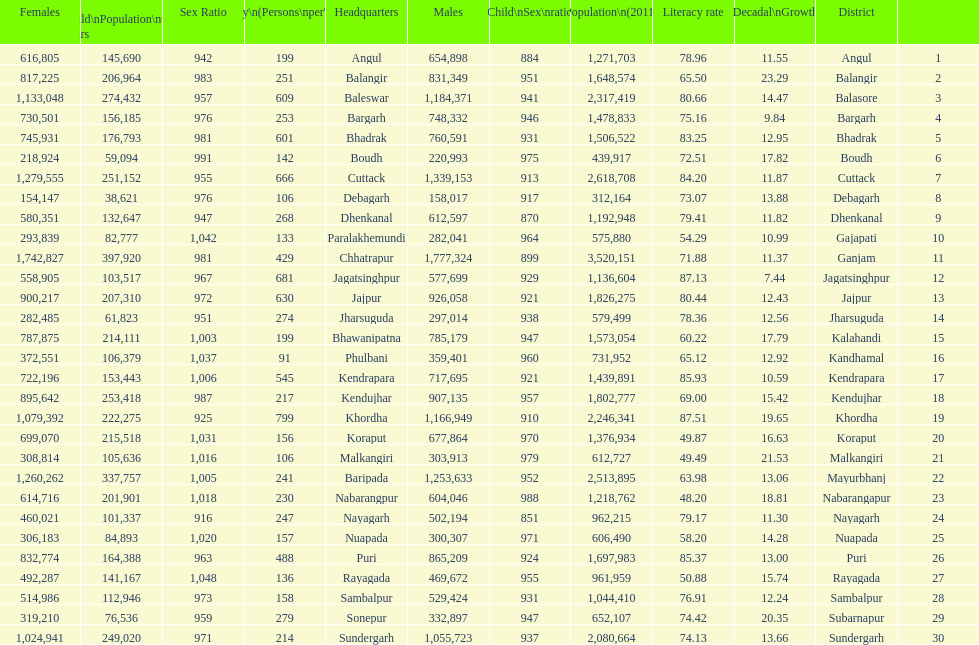Can you parse all the data within this table? {'header': ['Females', 'Child\\nPopulation\\n0–6 years', 'Sex Ratio', 'Density\\n(Persons\\nper\\nkm2)', 'Headquarters', 'Males', 'Child\\nSex\\nratio', 'Population\\n(2011)', 'Literacy rate', 'Percentage\\nDecadal\\nGrowth\\n2001-2011', 'District', ''], 'rows': [['616,805', '145,690', '942', '199', 'Angul', '654,898', '884', '1,271,703', '78.96', '11.55', 'Angul', '1'], ['817,225', '206,964', '983', '251', 'Balangir', '831,349', '951', '1,648,574', '65.50', '23.29', 'Balangir', '2'], ['1,133,048', '274,432', '957', '609', 'Baleswar', '1,184,371', '941', '2,317,419', '80.66', '14.47', 'Balasore', '3'], ['730,501', '156,185', '976', '253', 'Bargarh', '748,332', '946', '1,478,833', '75.16', '9.84', 'Bargarh', '4'], ['745,931', '176,793', '981', '601', 'Bhadrak', '760,591', '931', '1,506,522', '83.25', '12.95', 'Bhadrak', '5'], ['218,924', '59,094', '991', '142', 'Boudh', '220,993', '975', '439,917', '72.51', '17.82', 'Boudh', '6'], ['1,279,555', '251,152', '955', '666', 'Cuttack', '1,339,153', '913', '2,618,708', '84.20', '11.87', 'Cuttack', '7'], ['154,147', '38,621', '976', '106', 'Debagarh', '158,017', '917', '312,164', '73.07', '13.88', 'Debagarh', '8'], ['580,351', '132,647', '947', '268', 'Dhenkanal', '612,597', '870', '1,192,948', '79.41', '11.82', 'Dhenkanal', '9'], ['293,839', '82,777', '1,042', '133', 'Paralakhemundi', '282,041', '964', '575,880', '54.29', '10.99', 'Gajapati', '10'], ['1,742,827', '397,920', '981', '429', 'Chhatrapur', '1,777,324', '899', '3,520,151', '71.88', '11.37', 'Ganjam', '11'], ['558,905', '103,517', '967', '681', 'Jagatsinghpur', '577,699', '929', '1,136,604', '87.13', '7.44', 'Jagatsinghpur', '12'], ['900,217', '207,310', '972', '630', 'Jajpur', '926,058', '921', '1,826,275', '80.44', '12.43', 'Jajpur', '13'], ['282,485', '61,823', '951', '274', 'Jharsuguda', '297,014', '938', '579,499', '78.36', '12.56', 'Jharsuguda', '14'], ['787,875', '214,111', '1,003', '199', 'Bhawanipatna', '785,179', '947', '1,573,054', '60.22', '17.79', 'Kalahandi', '15'], ['372,551', '106,379', '1,037', '91', 'Phulbani', '359,401', '960', '731,952', '65.12', '12.92', 'Kandhamal', '16'], ['722,196', '153,443', '1,006', '545', 'Kendrapara', '717,695', '921', '1,439,891', '85.93', '10.59', 'Kendrapara', '17'], ['895,642', '253,418', '987', '217', 'Kendujhar', '907,135', '957', '1,802,777', '69.00', '15.42', 'Kendujhar', '18'], ['1,079,392', '222,275', '925', '799', 'Khordha', '1,166,949', '910', '2,246,341', '87.51', '19.65', 'Khordha', '19'], ['699,070', '215,518', '1,031', '156', 'Koraput', '677,864', '970', '1,376,934', '49.87', '16.63', 'Koraput', '20'], ['308,814', '105,636', '1,016', '106', 'Malkangiri', '303,913', '979', '612,727', '49.49', '21.53', 'Malkangiri', '21'], ['1,260,262', '337,757', '1,005', '241', 'Baripada', '1,253,633', '952', '2,513,895', '63.98', '13.06', 'Mayurbhanj', '22'], ['614,716', '201,901', '1,018', '230', 'Nabarangpur', '604,046', '988', '1,218,762', '48.20', '18.81', 'Nabarangapur', '23'], ['460,021', '101,337', '916', '247', 'Nayagarh', '502,194', '851', '962,215', '79.17', '11.30', 'Nayagarh', '24'], ['306,183', '84,893', '1,020', '157', 'Nuapada', '300,307', '971', '606,490', '58.20', '14.28', 'Nuapada', '25'], ['832,774', '164,388', '963', '488', 'Puri', '865,209', '924', '1,697,983', '85.37', '13.00', 'Puri', '26'], ['492,287', '141,167', '1,048', '136', 'Rayagada', '469,672', '955', '961,959', '50.88', '15.74', 'Rayagada', '27'], ['514,986', '112,946', '973', '158', 'Sambalpur', '529,424', '931', '1,044,410', '76.91', '12.24', 'Sambalpur', '28'], ['319,210', '76,536', '959', '279', 'Sonepur', '332,897', '947', '652,107', '74.42', '20.35', 'Subarnapur', '29'], ['1,024,941', '249,020', '971', '214', 'Sundergarh', '1,055,723', '937', '2,080,664', '74.13', '13.66', 'Sundergarh', '30']]} Which district has a higher population, angul or cuttack? Cuttack. 